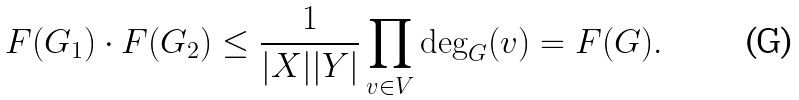Convert formula to latex. <formula><loc_0><loc_0><loc_500><loc_500>F ( G _ { 1 } ) \cdot F ( G _ { 2 } ) \leq \frac { 1 } { | X | | Y | } \prod _ { v \in V } \deg _ { G } ( v ) = F ( G ) .</formula> 